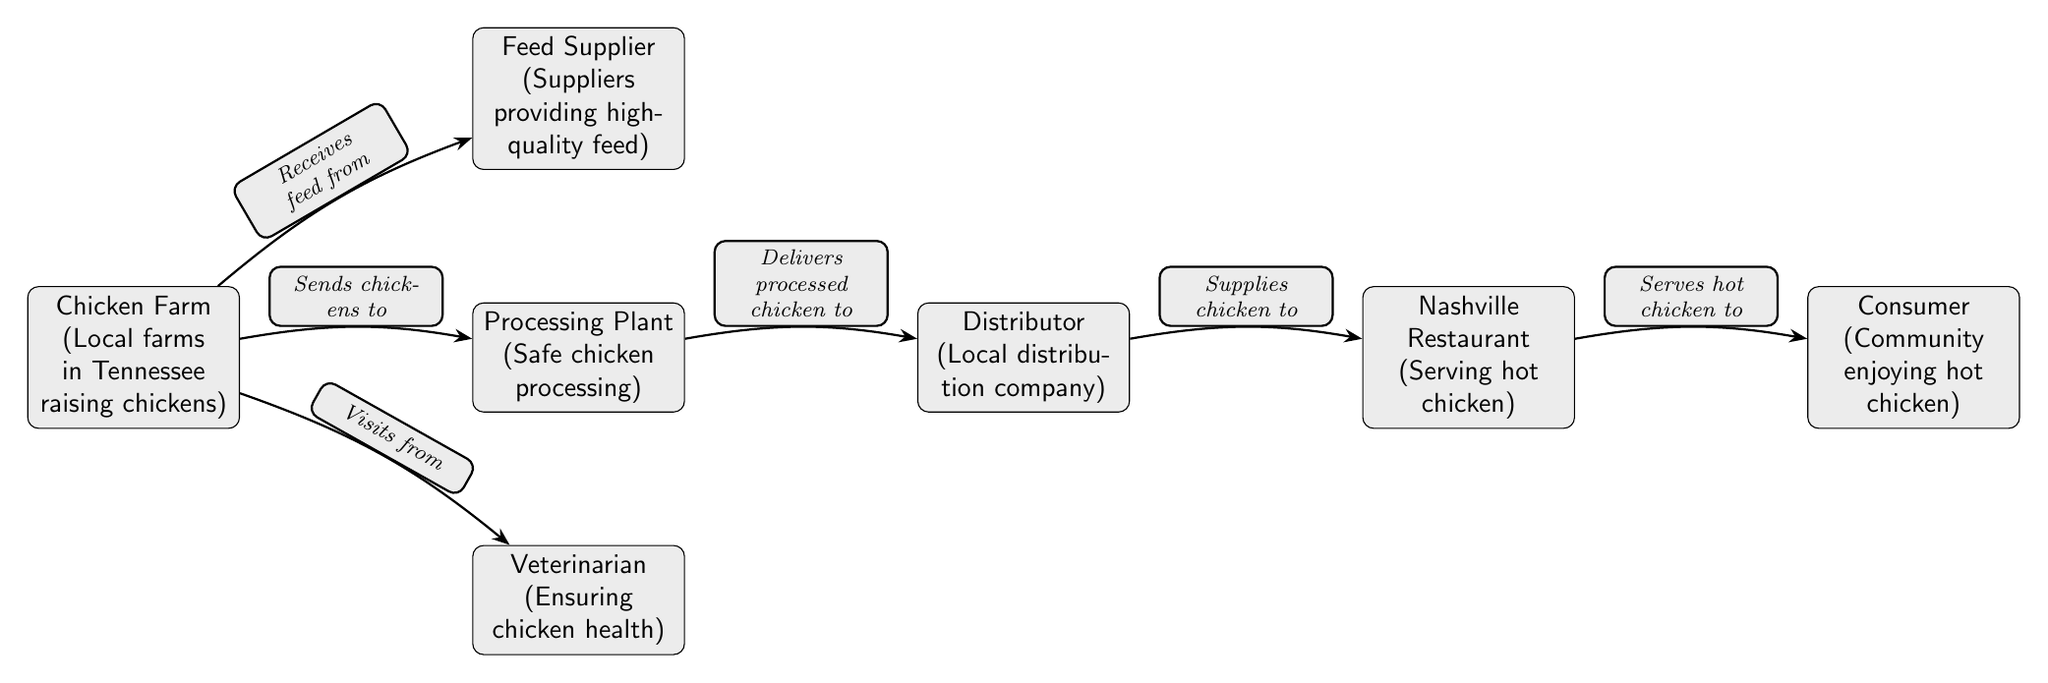What is the first node in the food chain? The first node represents the Chicken Farm, which is where the journey of Nashville hot chicken begins.
Answer: Chicken Farm How many participants are there in the food chain? The diagram has a total of six participants, counting from the Chicken Farm to the Consumer.
Answer: 6 What does the Veterinarian ensure? The Veterinarian's role is to ensure the health of the chickens before they are processed.
Answer: Chicken health Which node receives feed from the feed supplier? The Chicken Farm receives feed from the feed supplier, as indicated by the arrow directed from the feed supplier to the chicken farm.
Answer: Chicken Farm Who serves hot chicken to the community? The Nashville Restaurant is the node that serves hot chicken to the community, connecting directly to the consumer.
Answer: Nashville Restaurant What does the Processing Plant do? The Processing Plant processes the chickens safely and then sends them to be distributed.
Answer: Safe chicken processing Where does the processed chicken go after the Processing Plant? After processing, the chicken is delivered to the Distributor, which is the next step in the chain.
Answer: Distributor How many edges are there in the diagram? The diagram has five edges indicating the flow from one participant to the next, from the farm to the consumer.
Answer: 5 What role does the Distributor play? The Distributor supplies the processed chicken to the Nashville Restaurant, acting as an intermediary in the flow.
Answer: Local distribution company 